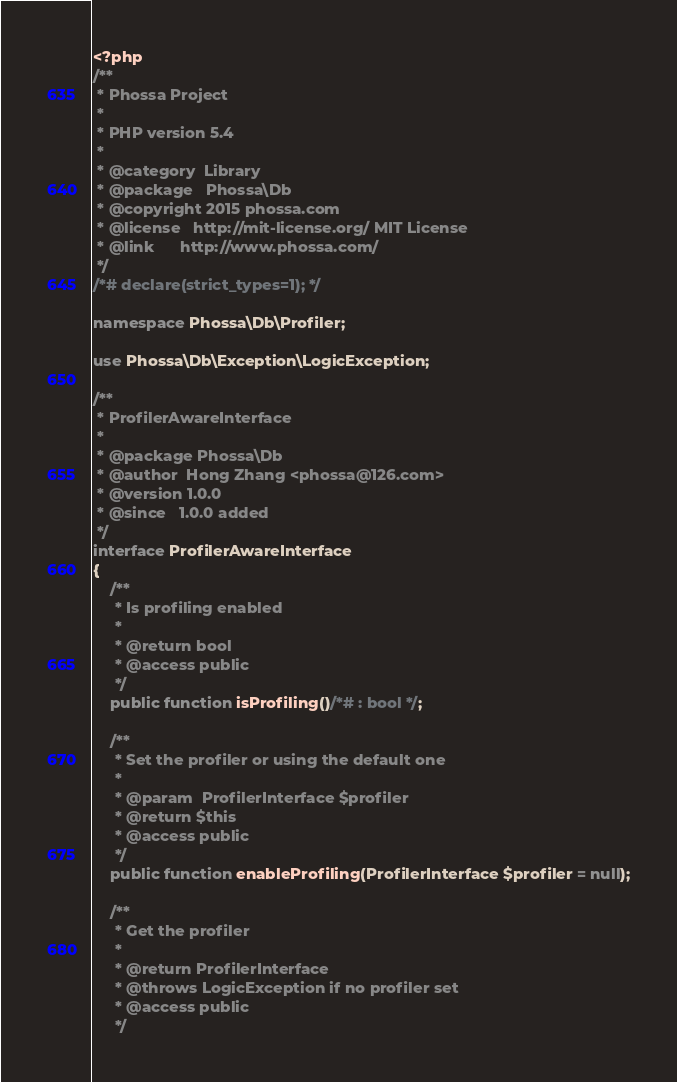<code> <loc_0><loc_0><loc_500><loc_500><_PHP_><?php
/**
 * Phossa Project
 *
 * PHP version 5.4
 *
 * @category  Library
 * @package   Phossa\Db
 * @copyright 2015 phossa.com
 * @license   http://mit-license.org/ MIT License
 * @link      http://www.phossa.com/
 */
/*# declare(strict_types=1); */

namespace Phossa\Db\Profiler;

use Phossa\Db\Exception\LogicException;

/**
 * ProfilerAwareInterface
 *
 * @package Phossa\Db
 * @author  Hong Zhang <phossa@126.com>
 * @version 1.0.0
 * @since   1.0.0 added
 */
interface ProfilerAwareInterface
{
    /**
     * Is profiling enabled
     *
     * @return bool
     * @access public
     */
    public function isProfiling()/*# : bool */;

    /**
     * Set the profiler or using the default one
     *
     * @param  ProfilerInterface $profiler
     * @return $this
     * @access public
     */
    public function enableProfiling(ProfilerInterface $profiler = null);

    /**
     * Get the profiler
     *
     * @return ProfilerInterface
     * @throws LogicException if no profiler set
     * @access public
     */</code> 